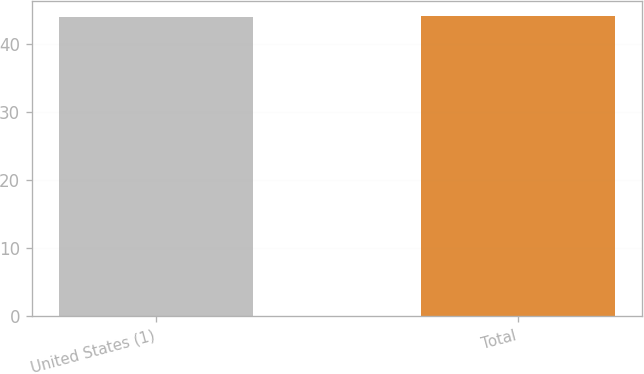<chart> <loc_0><loc_0><loc_500><loc_500><bar_chart><fcel>United States (1)<fcel>Total<nl><fcel>44<fcel>44.1<nl></chart> 